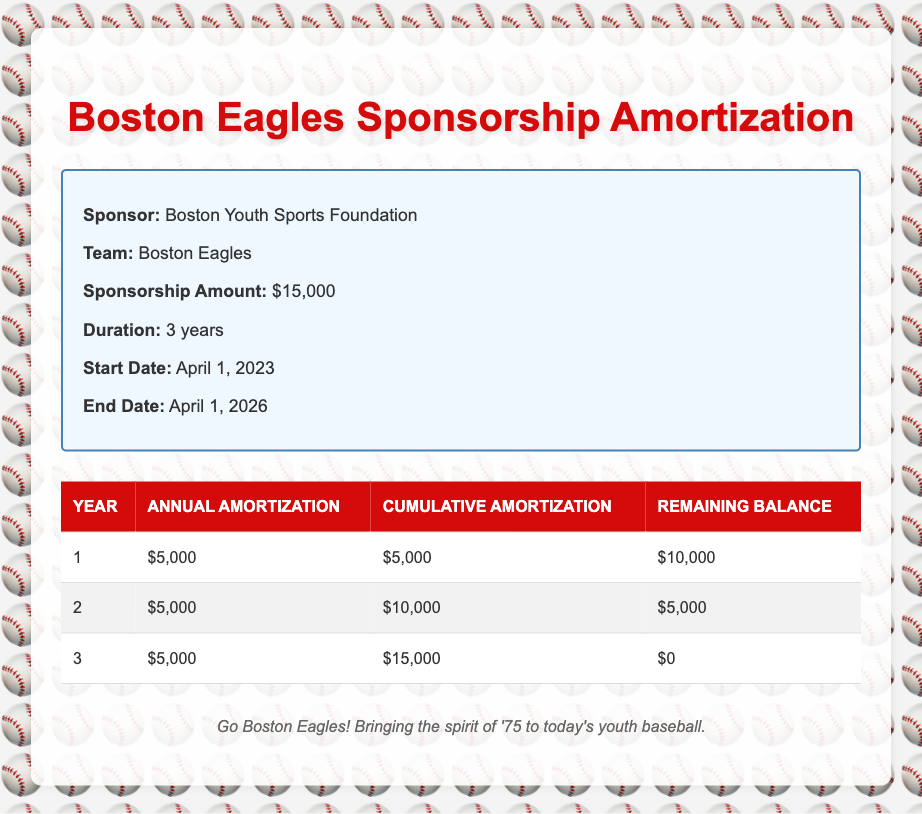What is the annual amortization amount for the first year? The table shows the annual amortization amount for each year listed. For the first year, the figure is clearly marked as $5,000.
Answer: $5,000 What is the cumulative amortization at the end of the second year? The cumulative amortization at the end of the second year is provided directly in the table. It shows $10,000 for year 2 cumulative amortization.
Answer: $10,000 Is the remaining balance zero at the end of the duration? The last row of the table indicates that the remaining balance for year 3 is $0, which means no amount is left to amortize at the end of the duration.
Answer: Yes How much total has been amortized after two years? The cumulative amortization after two years is $10,000 as stated in the table. Since the amortization is annual, it is simply the amounts added together until year 2.
Answer: $10,000 What is the remaining balance after the first year? The remaining balance after the first year is given in the table, specifically as $10,000. It directly shows the amount left after the first year’s amortization.
Answer: $10,000 How much does the Boston Eagles pay annually on average over the three years? The total amortization amount of $15,000 divided by 3 years equals an average annual payment. Thus, $15,000 / 3 = $5,000.
Answer: $5,000 What is the difference in cumulative amortization from year 1 to year 3? The cumulative amortization for year 3 is $15,000, and for year 1 it is $5,000. The difference is calculated by subtracting year 1 from year 3: $15,000 - $5,000 = $10,000.
Answer: $10,000 In which year does the Boston Eagles reach a remaining balance of $5,000? The table indicates that the remaining balance of $5,000 occurs in the second year. This is evident from the remaining balance column for year 2.
Answer: Year 2 What is the total amortization amount at the end of the sponsorship duration? The total amortization at the end of the sponsorship duration is found in the cumulative amortization for year 3, which is $15,000.
Answer: $15,000 